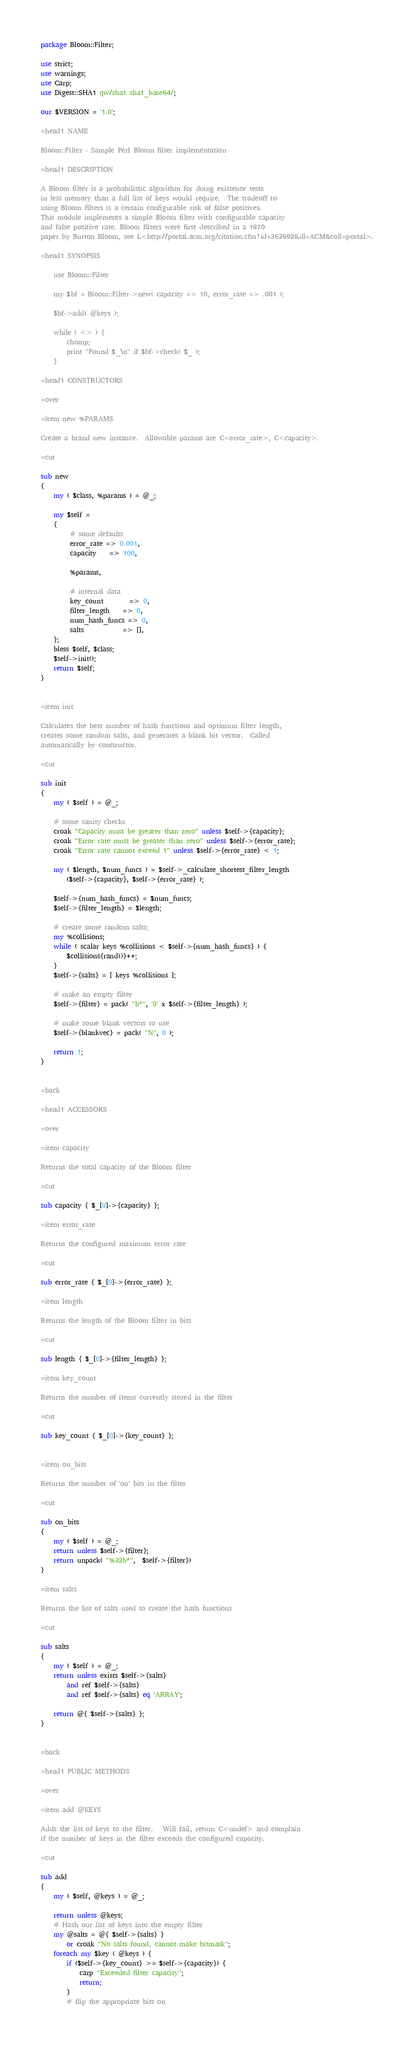<code> <loc_0><loc_0><loc_500><loc_500><_Perl_>package Bloom::Filter;

use strict;
use warnings;
use Carp;
use Digest::SHA1 qw/sha1 sha1_base64/;

our $VERSION = '1.0';

=head1 NAME
    
Bloom::Filter - Sample Perl Bloom filter implementation
    
=head1 DESCRIPTION

A Bloom filter is a probabilistic algorithm for doing existence tests
in less memory than a full list of keys would require.  The tradeoff to
using Bloom filters is a certain configurable risk of false positives. 
This module implements a simple Bloom filter with configurable capacity
and false positive rate. Bloom filters were first described in a 1970 
paper by Burton Bloom, see L<http://portal.acm.org/citation.cfm?id=362692&dl=ACM&coll=portal>.

=head1 SYNOPSIS

	use Bloom::Filter

	my $bf = Bloom::Filter->new( capacity => 10, error_rate => .001 );

	$bf->add( @keys );

	while ( <> ) {
		chomp;
		print "Found $_\n" if $bf->check( $_ );
	}

=head1 CONSTRUCTORS

=over 

=item new %PARAMS

Create a brand new instance.  Allowable params are C<error_rate>, C<capacity>.

=cut

sub new 
{
	my ( $class, %params ) = @_;

	my $self = 
	{  
		 # some defaults
		 error_rate => 0.001, 
		 capacity 	=> 100, 
			 
		 %params,
		 
		 # internal data
		 key_count 		=> 0,
		 filter_length 	=> 0,
		 num_hash_funcs => 0,
		 salts 			=> [],
	};
	bless $self, $class;
	$self->init();
	return $self;
}


=item init

Calculates the best number of hash functions and optimum filter length,
creates some random salts, and generates a blank bit vector.  Called
automatically by constructor.

=cut

sub init 
{
	my ( $self ) = @_;
	
	# some sanity checks
	croak "Capacity must be greater than zero" unless $self->{capacity};
	croak "Error rate must be greater than zero" unless $self->{error_rate};
	croak "Error rate cannot exceed 1" unless $self->{error_rate} < 1;
                                     	
	my ( $length, $num_funcs ) = $self->_calculate_shortest_filter_length
	    ($self->{capacity}, $self->{error_rate} );
	
	$self->{num_hash_funcs} = $num_funcs;
	$self->{filter_length} = $length;
	
	# create some random salts;
	my %collisions;
	while ( scalar keys %collisions < $self->{num_hash_funcs} ) {
		$collisions{rand()}++;
	}
	$self->{salts} = [ keys %collisions ];
	
	# make an empty filter
	$self->{filter} = pack( "b*", '0' x $self->{filter_length} );
	
	# make some blank vectors to use
	$self->{blankvec} = pack( "N", 0 ); 
	
	return 1;
}


=back

=head1 ACCESSORS

=over 

=item capacity

Returns the total capacity of the Bloom filter

=cut

sub capacity { $_[0]->{capacity} };

=item error_rate

Returns the configured maximum error rate

=cut

sub error_rate { $_[0]->{error_rate} };

=item length

Returns the length of the Bloom filter in bits

=cut

sub length { $_[0]->{filter_length} };

=item key_count

Returns the number of items currently stored in the filter

=cut

sub key_count { $_[0]->{key_count} };


=item on_bits

Returns the number of 'on' bits in the filter

=cut

sub on_bits 
{
	my ( $self ) = @_;
	return unless $self->{filter};
	return unpack( "%32b*",  $self->{filter})
}

=item salts 

Returns the list of salts used to create the hash functions

=cut

sub salts 
{ 
	my ( $self ) = @_;
	return unless exists $self->{salts}
		and ref $self->{salts}
		and ref $self->{salts} eq 'ARRAY';

	return @{ $self->{salts} };
}


=back

=head1 PUBLIC METHODS

=over

=item add @KEYS

Adds the list of keys to the filter.   Will fail, return C<undef> and complain
if the number of keys in the filter exceeds the configured capacity.

=cut

sub add 
{
	my ( $self, @keys ) = @_;
	
	return unless @keys;
	# Hash our list of keys into the empty filter
	my @salts = @{ $self->{salts} }
		or croak "No salts found, cannot make bitmask";
	foreach my $key ( @keys ) {
	    if ($self->{key_count} >= $self->{capacity}) {	
			carp "Exceeded filter capacity";
			return;
	    }
	    # flip the appropriate bits on</code> 